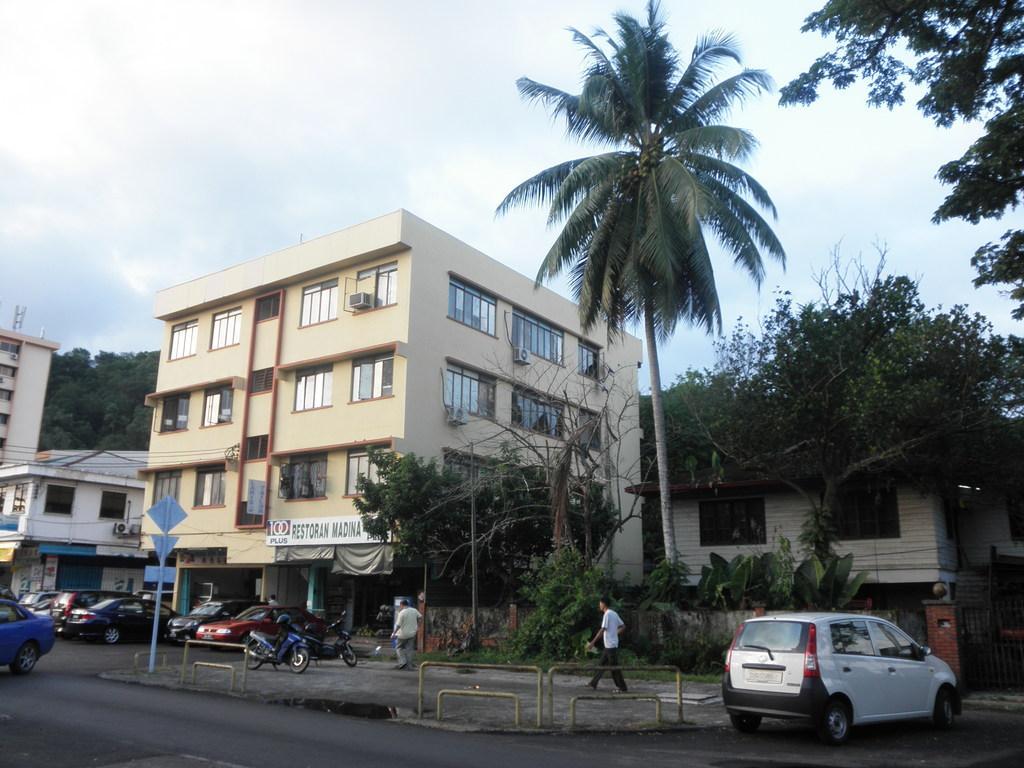Please provide a concise description of this image. These are the buildings with the windows. This looks like a name board, which is attached to the building wall. I can see two people walking. These look like the barricades. I can see the cars and the motorbikes, which are parked. These are the trees. On the right side of the image, that looks like a gate. Here is the sky. I think these are the boats, which are attached to a pole. 